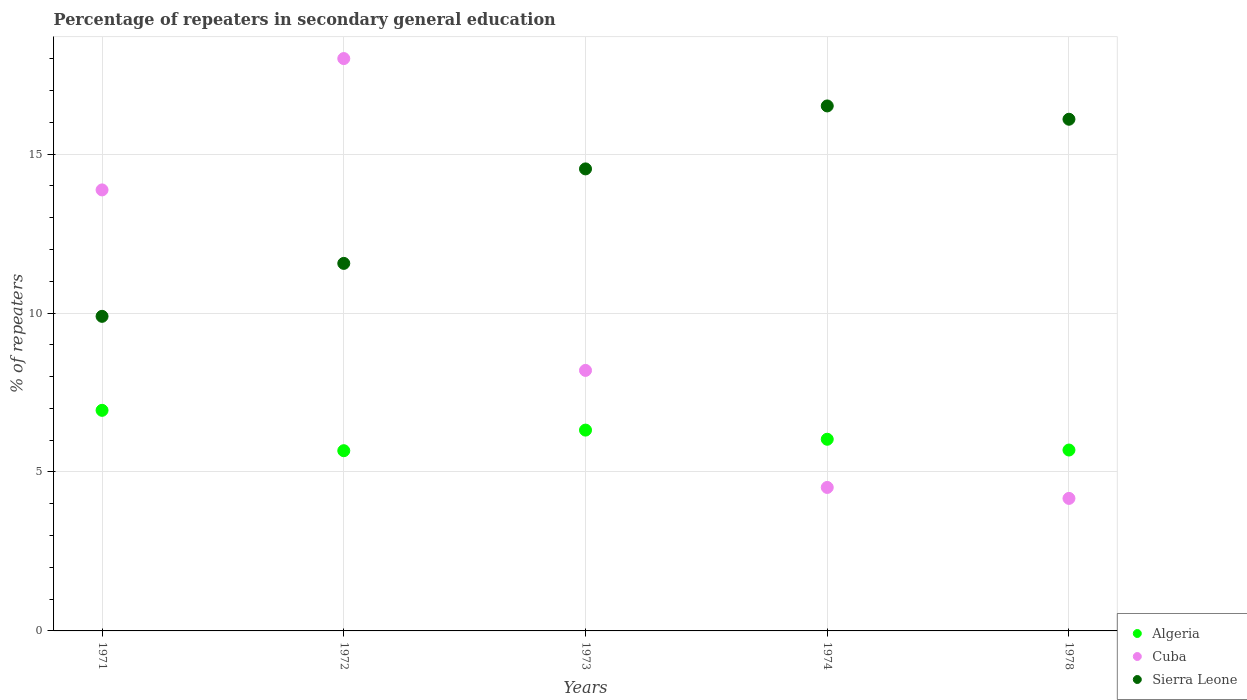How many different coloured dotlines are there?
Give a very brief answer. 3. What is the percentage of repeaters in secondary general education in Cuba in 1972?
Your answer should be very brief. 18. Across all years, what is the maximum percentage of repeaters in secondary general education in Algeria?
Keep it short and to the point. 6.94. Across all years, what is the minimum percentage of repeaters in secondary general education in Algeria?
Provide a short and direct response. 5.67. In which year was the percentage of repeaters in secondary general education in Cuba minimum?
Provide a short and direct response. 1978. What is the total percentage of repeaters in secondary general education in Cuba in the graph?
Offer a very short reply. 48.75. What is the difference between the percentage of repeaters in secondary general education in Cuba in 1973 and that in 1974?
Your answer should be compact. 3.68. What is the difference between the percentage of repeaters in secondary general education in Sierra Leone in 1972 and the percentage of repeaters in secondary general education in Algeria in 1974?
Keep it short and to the point. 5.53. What is the average percentage of repeaters in secondary general education in Cuba per year?
Your answer should be compact. 9.75. In the year 1974, what is the difference between the percentage of repeaters in secondary general education in Algeria and percentage of repeaters in secondary general education in Sierra Leone?
Keep it short and to the point. -10.48. In how many years, is the percentage of repeaters in secondary general education in Cuba greater than 2 %?
Provide a succinct answer. 5. What is the ratio of the percentage of repeaters in secondary general education in Sierra Leone in 1973 to that in 1978?
Offer a very short reply. 0.9. Is the percentage of repeaters in secondary general education in Sierra Leone in 1972 less than that in 1974?
Your response must be concise. Yes. Is the difference between the percentage of repeaters in secondary general education in Algeria in 1972 and 1978 greater than the difference between the percentage of repeaters in secondary general education in Sierra Leone in 1972 and 1978?
Your answer should be very brief. Yes. What is the difference between the highest and the second highest percentage of repeaters in secondary general education in Sierra Leone?
Your answer should be very brief. 0.42. What is the difference between the highest and the lowest percentage of repeaters in secondary general education in Sierra Leone?
Provide a succinct answer. 6.62. In how many years, is the percentage of repeaters in secondary general education in Sierra Leone greater than the average percentage of repeaters in secondary general education in Sierra Leone taken over all years?
Your answer should be compact. 3. Is it the case that in every year, the sum of the percentage of repeaters in secondary general education in Algeria and percentage of repeaters in secondary general education in Cuba  is greater than the percentage of repeaters in secondary general education in Sierra Leone?
Provide a short and direct response. No. Does the percentage of repeaters in secondary general education in Cuba monotonically increase over the years?
Provide a succinct answer. No. Is the percentage of repeaters in secondary general education in Algeria strictly greater than the percentage of repeaters in secondary general education in Sierra Leone over the years?
Offer a very short reply. No. How many years are there in the graph?
Ensure brevity in your answer.  5. What is the difference between two consecutive major ticks on the Y-axis?
Provide a short and direct response. 5. Does the graph contain any zero values?
Offer a terse response. No. Where does the legend appear in the graph?
Your response must be concise. Bottom right. How many legend labels are there?
Offer a terse response. 3. What is the title of the graph?
Provide a short and direct response. Percentage of repeaters in secondary general education. Does "Zimbabwe" appear as one of the legend labels in the graph?
Keep it short and to the point. No. What is the label or title of the Y-axis?
Offer a very short reply. % of repeaters. What is the % of repeaters in Algeria in 1971?
Offer a very short reply. 6.94. What is the % of repeaters in Cuba in 1971?
Provide a succinct answer. 13.87. What is the % of repeaters of Sierra Leone in 1971?
Offer a terse response. 9.9. What is the % of repeaters in Algeria in 1972?
Offer a very short reply. 5.67. What is the % of repeaters in Cuba in 1972?
Give a very brief answer. 18. What is the % of repeaters in Sierra Leone in 1972?
Keep it short and to the point. 11.56. What is the % of repeaters of Algeria in 1973?
Provide a succinct answer. 6.32. What is the % of repeaters of Cuba in 1973?
Give a very brief answer. 8.19. What is the % of repeaters of Sierra Leone in 1973?
Give a very brief answer. 14.53. What is the % of repeaters in Algeria in 1974?
Provide a succinct answer. 6.03. What is the % of repeaters in Cuba in 1974?
Offer a terse response. 4.51. What is the % of repeaters in Sierra Leone in 1974?
Offer a very short reply. 16.51. What is the % of repeaters in Algeria in 1978?
Provide a succinct answer. 5.69. What is the % of repeaters of Cuba in 1978?
Make the answer very short. 4.17. What is the % of repeaters of Sierra Leone in 1978?
Provide a short and direct response. 16.1. Across all years, what is the maximum % of repeaters in Algeria?
Offer a very short reply. 6.94. Across all years, what is the maximum % of repeaters in Cuba?
Your response must be concise. 18. Across all years, what is the maximum % of repeaters in Sierra Leone?
Your answer should be compact. 16.51. Across all years, what is the minimum % of repeaters in Algeria?
Ensure brevity in your answer.  5.67. Across all years, what is the minimum % of repeaters in Cuba?
Keep it short and to the point. 4.17. Across all years, what is the minimum % of repeaters in Sierra Leone?
Make the answer very short. 9.9. What is the total % of repeaters of Algeria in the graph?
Offer a terse response. 30.64. What is the total % of repeaters in Cuba in the graph?
Your response must be concise. 48.75. What is the total % of repeaters in Sierra Leone in the graph?
Your response must be concise. 68.6. What is the difference between the % of repeaters of Algeria in 1971 and that in 1972?
Your response must be concise. 1.27. What is the difference between the % of repeaters of Cuba in 1971 and that in 1972?
Your answer should be compact. -4.13. What is the difference between the % of repeaters of Sierra Leone in 1971 and that in 1972?
Ensure brevity in your answer.  -1.67. What is the difference between the % of repeaters in Algeria in 1971 and that in 1973?
Your response must be concise. 0.62. What is the difference between the % of repeaters of Cuba in 1971 and that in 1973?
Your response must be concise. 5.68. What is the difference between the % of repeaters of Sierra Leone in 1971 and that in 1973?
Ensure brevity in your answer.  -4.64. What is the difference between the % of repeaters in Algeria in 1971 and that in 1974?
Make the answer very short. 0.91. What is the difference between the % of repeaters of Cuba in 1971 and that in 1974?
Your answer should be compact. 9.36. What is the difference between the % of repeaters in Sierra Leone in 1971 and that in 1974?
Ensure brevity in your answer.  -6.62. What is the difference between the % of repeaters of Algeria in 1971 and that in 1978?
Give a very brief answer. 1.25. What is the difference between the % of repeaters in Cuba in 1971 and that in 1978?
Your answer should be compact. 9.7. What is the difference between the % of repeaters in Sierra Leone in 1971 and that in 1978?
Give a very brief answer. -6.2. What is the difference between the % of repeaters of Algeria in 1972 and that in 1973?
Your answer should be compact. -0.65. What is the difference between the % of repeaters in Cuba in 1972 and that in 1973?
Your answer should be compact. 9.81. What is the difference between the % of repeaters of Sierra Leone in 1972 and that in 1973?
Your response must be concise. -2.97. What is the difference between the % of repeaters of Algeria in 1972 and that in 1974?
Provide a short and direct response. -0.36. What is the difference between the % of repeaters in Cuba in 1972 and that in 1974?
Keep it short and to the point. 13.49. What is the difference between the % of repeaters in Sierra Leone in 1972 and that in 1974?
Your response must be concise. -4.95. What is the difference between the % of repeaters of Algeria in 1972 and that in 1978?
Keep it short and to the point. -0.02. What is the difference between the % of repeaters of Cuba in 1972 and that in 1978?
Keep it short and to the point. 13.84. What is the difference between the % of repeaters in Sierra Leone in 1972 and that in 1978?
Give a very brief answer. -4.53. What is the difference between the % of repeaters of Algeria in 1973 and that in 1974?
Your answer should be compact. 0.29. What is the difference between the % of repeaters in Cuba in 1973 and that in 1974?
Give a very brief answer. 3.68. What is the difference between the % of repeaters in Sierra Leone in 1973 and that in 1974?
Your answer should be very brief. -1.98. What is the difference between the % of repeaters in Algeria in 1973 and that in 1978?
Offer a very short reply. 0.63. What is the difference between the % of repeaters in Cuba in 1973 and that in 1978?
Make the answer very short. 4.03. What is the difference between the % of repeaters in Sierra Leone in 1973 and that in 1978?
Make the answer very short. -1.56. What is the difference between the % of repeaters of Algeria in 1974 and that in 1978?
Your answer should be very brief. 0.34. What is the difference between the % of repeaters in Cuba in 1974 and that in 1978?
Provide a short and direct response. 0.34. What is the difference between the % of repeaters in Sierra Leone in 1974 and that in 1978?
Make the answer very short. 0.42. What is the difference between the % of repeaters of Algeria in 1971 and the % of repeaters of Cuba in 1972?
Make the answer very short. -11.07. What is the difference between the % of repeaters in Algeria in 1971 and the % of repeaters in Sierra Leone in 1972?
Your answer should be very brief. -4.62. What is the difference between the % of repeaters of Cuba in 1971 and the % of repeaters of Sierra Leone in 1972?
Ensure brevity in your answer.  2.31. What is the difference between the % of repeaters in Algeria in 1971 and the % of repeaters in Cuba in 1973?
Offer a very short reply. -1.26. What is the difference between the % of repeaters in Algeria in 1971 and the % of repeaters in Sierra Leone in 1973?
Provide a short and direct response. -7.59. What is the difference between the % of repeaters of Cuba in 1971 and the % of repeaters of Sierra Leone in 1973?
Provide a succinct answer. -0.66. What is the difference between the % of repeaters in Algeria in 1971 and the % of repeaters in Cuba in 1974?
Provide a succinct answer. 2.43. What is the difference between the % of repeaters in Algeria in 1971 and the % of repeaters in Sierra Leone in 1974?
Provide a short and direct response. -9.58. What is the difference between the % of repeaters of Cuba in 1971 and the % of repeaters of Sierra Leone in 1974?
Give a very brief answer. -2.64. What is the difference between the % of repeaters of Algeria in 1971 and the % of repeaters of Cuba in 1978?
Offer a very short reply. 2.77. What is the difference between the % of repeaters in Algeria in 1971 and the % of repeaters in Sierra Leone in 1978?
Provide a succinct answer. -9.16. What is the difference between the % of repeaters of Cuba in 1971 and the % of repeaters of Sierra Leone in 1978?
Your response must be concise. -2.22. What is the difference between the % of repeaters of Algeria in 1972 and the % of repeaters of Cuba in 1973?
Your response must be concise. -2.53. What is the difference between the % of repeaters of Algeria in 1972 and the % of repeaters of Sierra Leone in 1973?
Keep it short and to the point. -8.86. What is the difference between the % of repeaters of Cuba in 1972 and the % of repeaters of Sierra Leone in 1973?
Offer a very short reply. 3.47. What is the difference between the % of repeaters in Algeria in 1972 and the % of repeaters in Cuba in 1974?
Offer a very short reply. 1.16. What is the difference between the % of repeaters in Algeria in 1972 and the % of repeaters in Sierra Leone in 1974?
Keep it short and to the point. -10.84. What is the difference between the % of repeaters in Cuba in 1972 and the % of repeaters in Sierra Leone in 1974?
Give a very brief answer. 1.49. What is the difference between the % of repeaters in Algeria in 1972 and the % of repeaters in Cuba in 1978?
Give a very brief answer. 1.5. What is the difference between the % of repeaters in Algeria in 1972 and the % of repeaters in Sierra Leone in 1978?
Your answer should be compact. -10.43. What is the difference between the % of repeaters of Cuba in 1972 and the % of repeaters of Sierra Leone in 1978?
Give a very brief answer. 1.91. What is the difference between the % of repeaters in Algeria in 1973 and the % of repeaters in Cuba in 1974?
Provide a succinct answer. 1.8. What is the difference between the % of repeaters of Algeria in 1973 and the % of repeaters of Sierra Leone in 1974?
Offer a very short reply. -10.2. What is the difference between the % of repeaters of Cuba in 1973 and the % of repeaters of Sierra Leone in 1974?
Keep it short and to the point. -8.32. What is the difference between the % of repeaters in Algeria in 1973 and the % of repeaters in Cuba in 1978?
Your response must be concise. 2.15. What is the difference between the % of repeaters in Algeria in 1973 and the % of repeaters in Sierra Leone in 1978?
Offer a terse response. -9.78. What is the difference between the % of repeaters in Cuba in 1973 and the % of repeaters in Sierra Leone in 1978?
Offer a terse response. -7.9. What is the difference between the % of repeaters in Algeria in 1974 and the % of repeaters in Cuba in 1978?
Offer a very short reply. 1.86. What is the difference between the % of repeaters of Algeria in 1974 and the % of repeaters of Sierra Leone in 1978?
Make the answer very short. -10.07. What is the difference between the % of repeaters in Cuba in 1974 and the % of repeaters in Sierra Leone in 1978?
Keep it short and to the point. -11.58. What is the average % of repeaters of Algeria per year?
Offer a terse response. 6.13. What is the average % of repeaters of Cuba per year?
Provide a succinct answer. 9.75. What is the average % of repeaters in Sierra Leone per year?
Your answer should be compact. 13.72. In the year 1971, what is the difference between the % of repeaters of Algeria and % of repeaters of Cuba?
Give a very brief answer. -6.93. In the year 1971, what is the difference between the % of repeaters of Algeria and % of repeaters of Sierra Leone?
Offer a terse response. -2.96. In the year 1971, what is the difference between the % of repeaters in Cuba and % of repeaters in Sierra Leone?
Offer a very short reply. 3.98. In the year 1972, what is the difference between the % of repeaters in Algeria and % of repeaters in Cuba?
Offer a terse response. -12.33. In the year 1972, what is the difference between the % of repeaters of Algeria and % of repeaters of Sierra Leone?
Keep it short and to the point. -5.89. In the year 1972, what is the difference between the % of repeaters in Cuba and % of repeaters in Sierra Leone?
Provide a short and direct response. 6.44. In the year 1973, what is the difference between the % of repeaters in Algeria and % of repeaters in Cuba?
Your response must be concise. -1.88. In the year 1973, what is the difference between the % of repeaters of Algeria and % of repeaters of Sierra Leone?
Your answer should be compact. -8.22. In the year 1973, what is the difference between the % of repeaters of Cuba and % of repeaters of Sierra Leone?
Your answer should be compact. -6.34. In the year 1974, what is the difference between the % of repeaters of Algeria and % of repeaters of Cuba?
Ensure brevity in your answer.  1.52. In the year 1974, what is the difference between the % of repeaters in Algeria and % of repeaters in Sierra Leone?
Keep it short and to the point. -10.48. In the year 1974, what is the difference between the % of repeaters of Cuba and % of repeaters of Sierra Leone?
Provide a succinct answer. -12. In the year 1978, what is the difference between the % of repeaters in Algeria and % of repeaters in Cuba?
Offer a very short reply. 1.52. In the year 1978, what is the difference between the % of repeaters in Algeria and % of repeaters in Sierra Leone?
Ensure brevity in your answer.  -10.41. In the year 1978, what is the difference between the % of repeaters in Cuba and % of repeaters in Sierra Leone?
Your answer should be compact. -11.93. What is the ratio of the % of repeaters of Algeria in 1971 to that in 1972?
Ensure brevity in your answer.  1.22. What is the ratio of the % of repeaters in Cuba in 1971 to that in 1972?
Offer a terse response. 0.77. What is the ratio of the % of repeaters of Sierra Leone in 1971 to that in 1972?
Provide a short and direct response. 0.86. What is the ratio of the % of repeaters in Algeria in 1971 to that in 1973?
Offer a terse response. 1.1. What is the ratio of the % of repeaters of Cuba in 1971 to that in 1973?
Keep it short and to the point. 1.69. What is the ratio of the % of repeaters in Sierra Leone in 1971 to that in 1973?
Offer a very short reply. 0.68. What is the ratio of the % of repeaters in Algeria in 1971 to that in 1974?
Make the answer very short. 1.15. What is the ratio of the % of repeaters in Cuba in 1971 to that in 1974?
Offer a very short reply. 3.07. What is the ratio of the % of repeaters of Sierra Leone in 1971 to that in 1974?
Your answer should be very brief. 0.6. What is the ratio of the % of repeaters of Algeria in 1971 to that in 1978?
Offer a terse response. 1.22. What is the ratio of the % of repeaters in Cuba in 1971 to that in 1978?
Make the answer very short. 3.33. What is the ratio of the % of repeaters of Sierra Leone in 1971 to that in 1978?
Keep it short and to the point. 0.61. What is the ratio of the % of repeaters of Algeria in 1972 to that in 1973?
Offer a terse response. 0.9. What is the ratio of the % of repeaters in Cuba in 1972 to that in 1973?
Offer a terse response. 2.2. What is the ratio of the % of repeaters in Sierra Leone in 1972 to that in 1973?
Provide a succinct answer. 0.8. What is the ratio of the % of repeaters of Algeria in 1972 to that in 1974?
Provide a short and direct response. 0.94. What is the ratio of the % of repeaters of Cuba in 1972 to that in 1974?
Your answer should be compact. 3.99. What is the ratio of the % of repeaters in Sierra Leone in 1972 to that in 1974?
Give a very brief answer. 0.7. What is the ratio of the % of repeaters of Cuba in 1972 to that in 1978?
Make the answer very short. 4.32. What is the ratio of the % of repeaters in Sierra Leone in 1972 to that in 1978?
Offer a terse response. 0.72. What is the ratio of the % of repeaters in Algeria in 1973 to that in 1974?
Keep it short and to the point. 1.05. What is the ratio of the % of repeaters in Cuba in 1973 to that in 1974?
Your response must be concise. 1.82. What is the ratio of the % of repeaters of Sierra Leone in 1973 to that in 1974?
Your response must be concise. 0.88. What is the ratio of the % of repeaters in Algeria in 1973 to that in 1978?
Make the answer very short. 1.11. What is the ratio of the % of repeaters in Cuba in 1973 to that in 1978?
Your answer should be very brief. 1.97. What is the ratio of the % of repeaters of Sierra Leone in 1973 to that in 1978?
Provide a short and direct response. 0.9. What is the ratio of the % of repeaters in Algeria in 1974 to that in 1978?
Your answer should be very brief. 1.06. What is the ratio of the % of repeaters in Cuba in 1974 to that in 1978?
Ensure brevity in your answer.  1.08. What is the ratio of the % of repeaters in Sierra Leone in 1974 to that in 1978?
Your answer should be compact. 1.03. What is the difference between the highest and the second highest % of repeaters of Algeria?
Offer a very short reply. 0.62. What is the difference between the highest and the second highest % of repeaters in Cuba?
Your answer should be very brief. 4.13. What is the difference between the highest and the second highest % of repeaters of Sierra Leone?
Your answer should be compact. 0.42. What is the difference between the highest and the lowest % of repeaters of Algeria?
Your answer should be compact. 1.27. What is the difference between the highest and the lowest % of repeaters of Cuba?
Make the answer very short. 13.84. What is the difference between the highest and the lowest % of repeaters of Sierra Leone?
Offer a terse response. 6.62. 